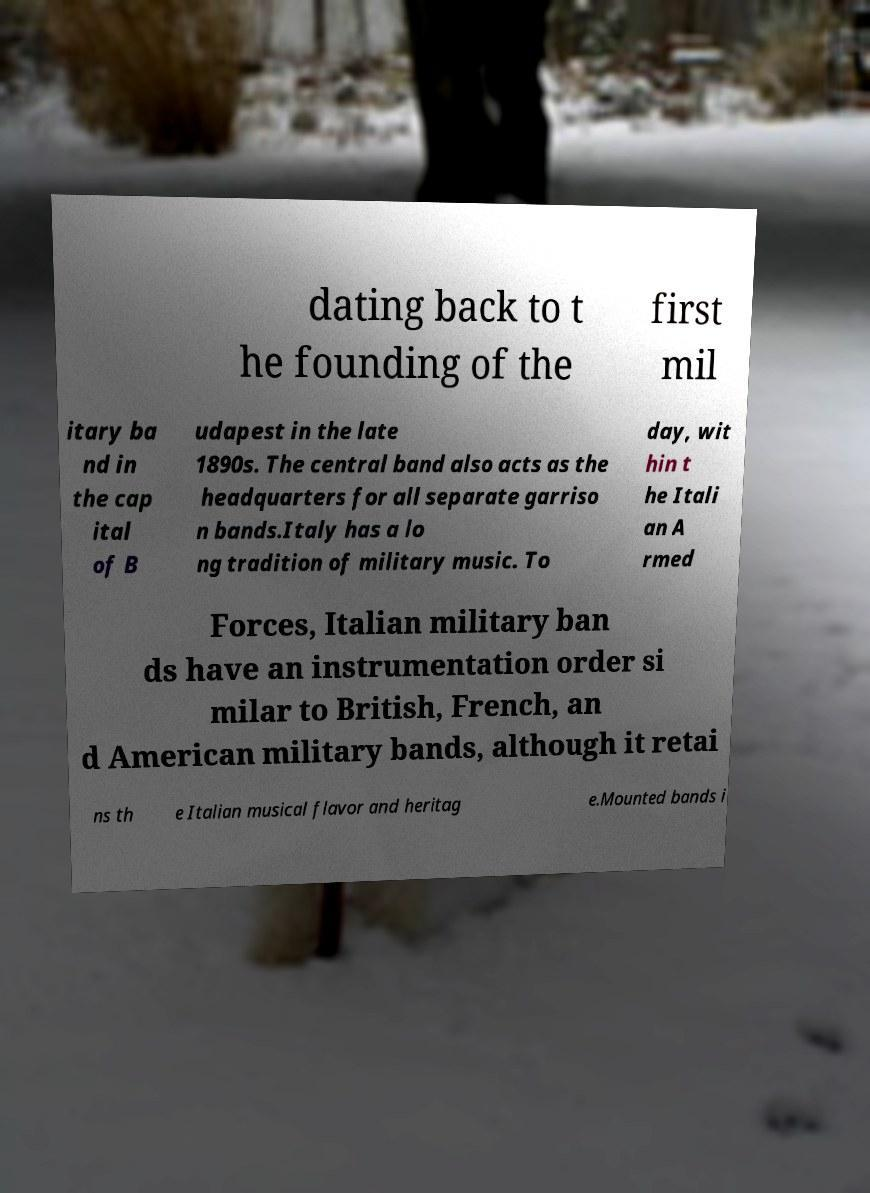Could you assist in decoding the text presented in this image and type it out clearly? dating back to t he founding of the first mil itary ba nd in the cap ital of B udapest in the late 1890s. The central band also acts as the headquarters for all separate garriso n bands.Italy has a lo ng tradition of military music. To day, wit hin t he Itali an A rmed Forces, Italian military ban ds have an instrumentation order si milar to British, French, an d American military bands, although it retai ns th e Italian musical flavor and heritag e.Mounted bands i 